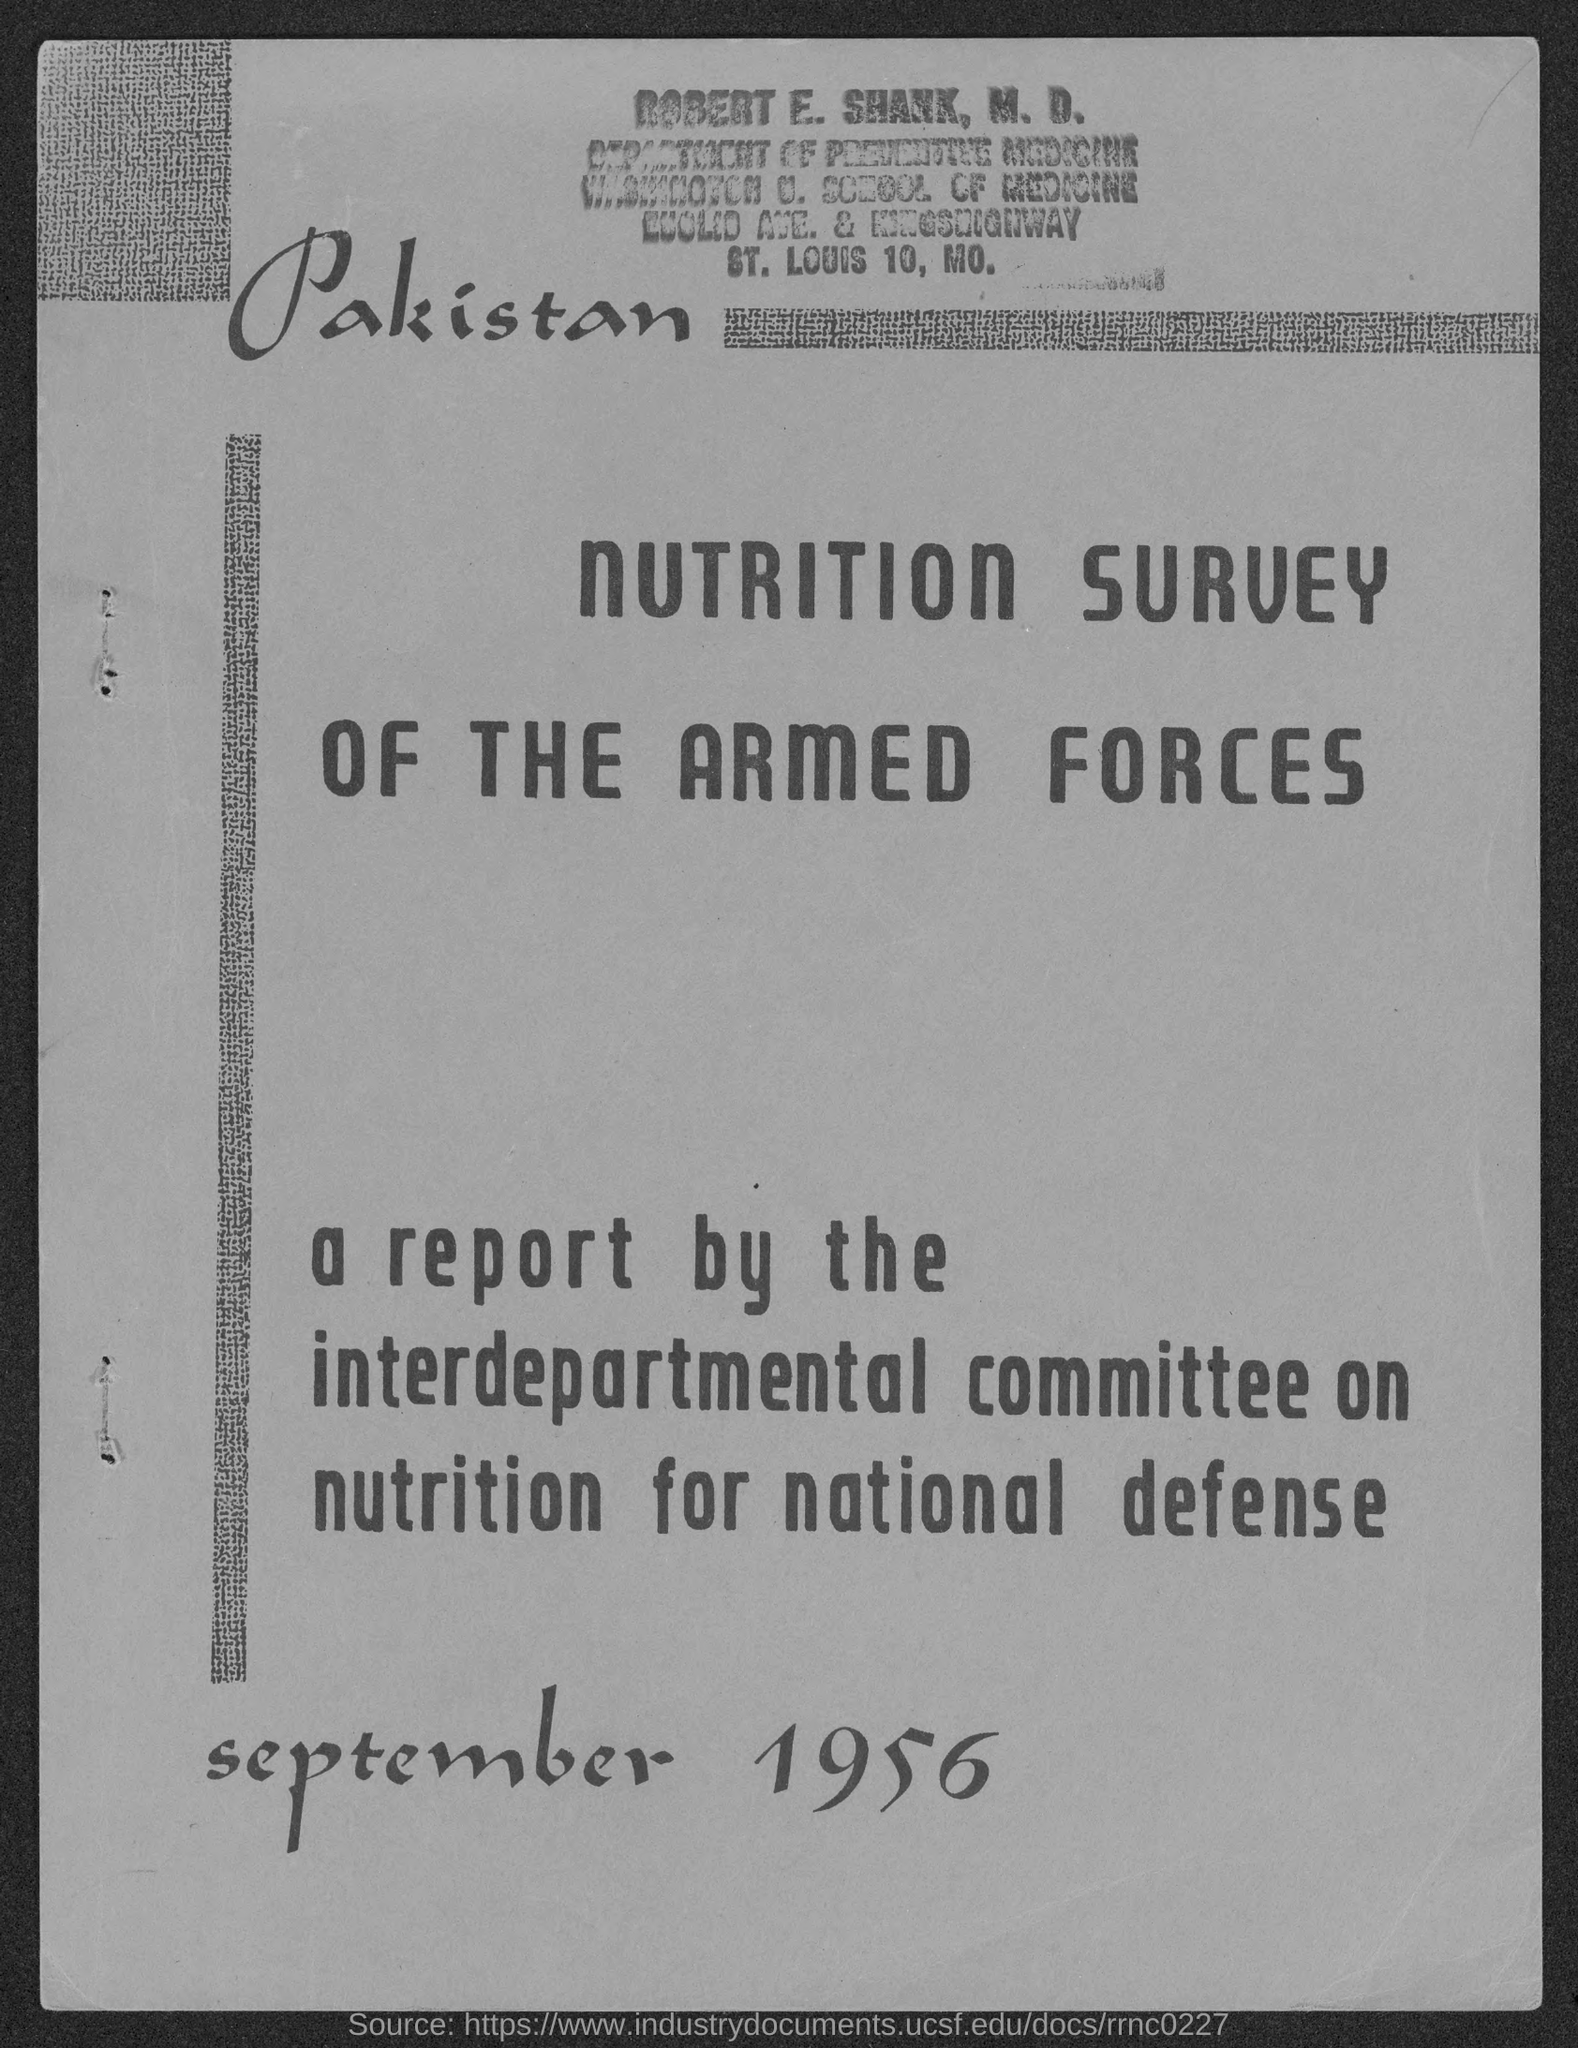What is the date mentioned in this document?
Ensure brevity in your answer.  SEPTEMBER 1956. 